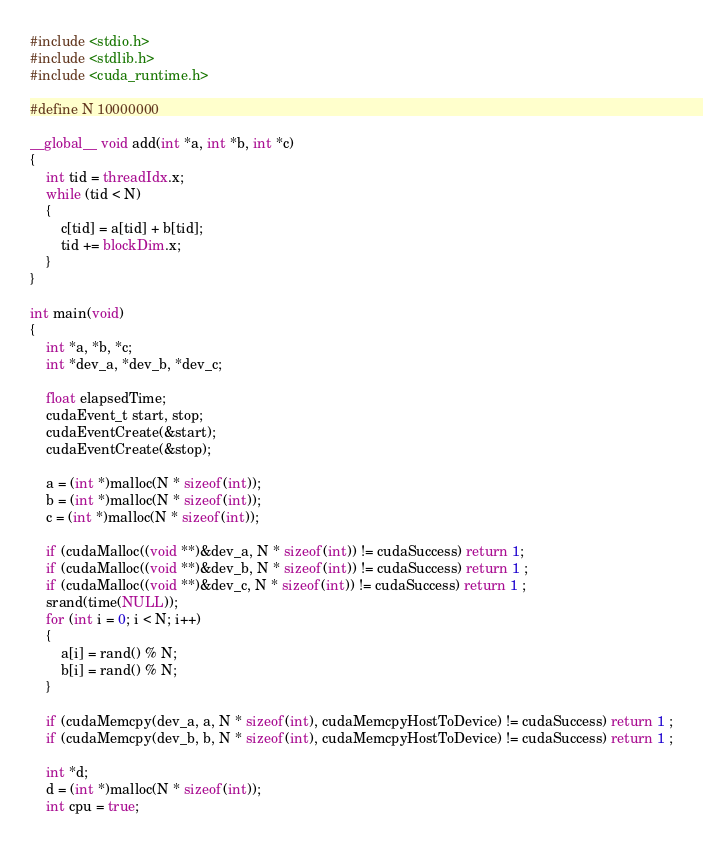<code> <loc_0><loc_0><loc_500><loc_500><_Cuda_>#include <stdio.h>
#include <stdlib.h>
#include <cuda_runtime.h>

#define N 10000000

__global__ void add(int *a, int *b, int *c)
{
    int tid = threadIdx.x;
    while (tid < N)
    {
        c[tid] = a[tid] + b[tid];
        tid += blockDim.x;
    }
}

int main(void)
{
    int *a, *b, *c;
    int *dev_a, *dev_b, *dev_c;

    float elapsedTime;
    cudaEvent_t start, stop;
    cudaEventCreate(&start);
    cudaEventCreate(&stop);

    a = (int *)malloc(N * sizeof(int));
    b = (int *)malloc(N * sizeof(int));
    c = (int *)malloc(N * sizeof(int));

    if (cudaMalloc((void **)&dev_a, N * sizeof(int)) != cudaSuccess) return 1;
    if (cudaMalloc((void **)&dev_b, N * sizeof(int)) != cudaSuccess) return 1 ;
    if (cudaMalloc((void **)&dev_c, N * sizeof(int)) != cudaSuccess) return 1 ;
    srand(time(NULL));
    for (int i = 0; i < N; i++)
    {
        a[i] = rand() % N;
        b[i] = rand() % N;
    }

    if (cudaMemcpy(dev_a, a, N * sizeof(int), cudaMemcpyHostToDevice) != cudaSuccess) return 1 ;
    if (cudaMemcpy(dev_b, b, N * sizeof(int), cudaMemcpyHostToDevice) != cudaSuccess) return 1 ;
    
    int *d;
    d = (int *)malloc(N * sizeof(int));
    int cpu = true;</code> 